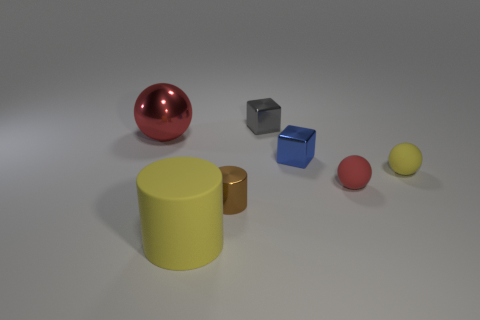Is there any other thing that is the same size as the red matte ball?
Provide a short and direct response. Yes. There is a small cylinder; are there any tiny gray shiny cubes in front of it?
Your answer should be compact. No. The tiny red thing is what shape?
Make the answer very short. Sphere. What number of objects are either tiny blocks that are in front of the gray cube or tiny red metallic objects?
Offer a very short reply. 1. What number of other things are there of the same color as the tiny shiny cylinder?
Keep it short and to the point. 0. There is a metallic ball; is its color the same as the tiny thing to the right of the red rubber thing?
Make the answer very short. No. There is another small metal thing that is the same shape as the small gray metallic thing; what is its color?
Give a very brief answer. Blue. Do the gray thing and the big object left of the large rubber object have the same material?
Give a very brief answer. Yes. What color is the metal cylinder?
Offer a very short reply. Brown. What color is the tiny metal thing in front of the yellow object behind the tiny brown thing that is in front of the metallic ball?
Keep it short and to the point. Brown. 